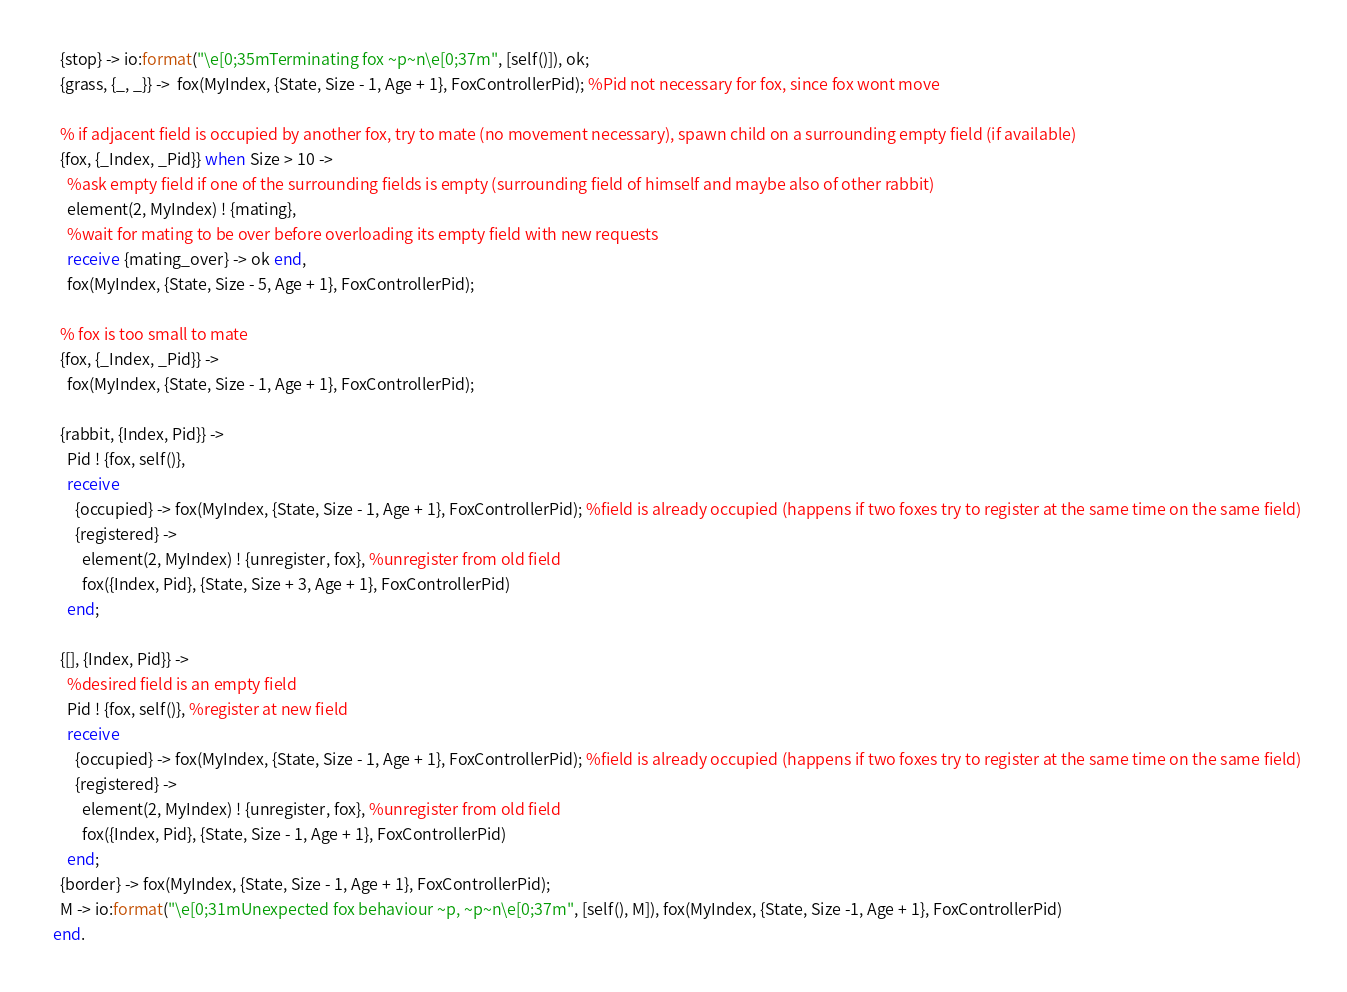Convert code to text. <code><loc_0><loc_0><loc_500><loc_500><_Erlang_>    {stop} -> io:format("\e[0;35mTerminating fox ~p~n\e[0;37m", [self()]), ok;
    {grass, {_, _}} ->  fox(MyIndex, {State, Size - 1, Age + 1}, FoxControllerPid); %Pid not necessary for fox, since fox wont move

    % if adjacent field is occupied by another fox, try to mate (no movement necessary), spawn child on a surrounding empty field (if available)
    {fox, {_Index, _Pid}} when Size > 10 ->
      %ask empty field if one of the surrounding fields is empty (surrounding field of himself and maybe also of other rabbit)
      element(2, MyIndex) ! {mating},
      %wait for mating to be over before overloading its empty field with new requests
      receive {mating_over} -> ok end,
      fox(MyIndex, {State, Size - 5, Age + 1}, FoxControllerPid);

    % fox is too small to mate
    {fox, {_Index, _Pid}} ->
      fox(MyIndex, {State, Size - 1, Age + 1}, FoxControllerPid);

    {rabbit, {Index, Pid}} ->
      Pid ! {fox, self()},
      receive
        {occupied} -> fox(MyIndex, {State, Size - 1, Age + 1}, FoxControllerPid); %field is already occupied (happens if two foxes try to register at the same time on the same field)
        {registered} ->
          element(2, MyIndex) ! {unregister, fox}, %unregister from old field
          fox({Index, Pid}, {State, Size + 3, Age + 1}, FoxControllerPid)
      end;

    {[], {Index, Pid}} ->
      %desired field is an empty field
      Pid ! {fox, self()}, %register at new field
      receive
        {occupied} -> fox(MyIndex, {State, Size - 1, Age + 1}, FoxControllerPid); %field is already occupied (happens if two foxes try to register at the same time on the same field)
        {registered} ->
          element(2, MyIndex) ! {unregister, fox}, %unregister from old field
          fox({Index, Pid}, {State, Size - 1, Age + 1}, FoxControllerPid)
      end;
    {border} -> fox(MyIndex, {State, Size - 1, Age + 1}, FoxControllerPid);
    M -> io:format("\e[0;31mUnexpected fox behaviour ~p, ~p~n\e[0;37m", [self(), M]), fox(MyIndex, {State, Size -1, Age + 1}, FoxControllerPid)
  end.</code> 